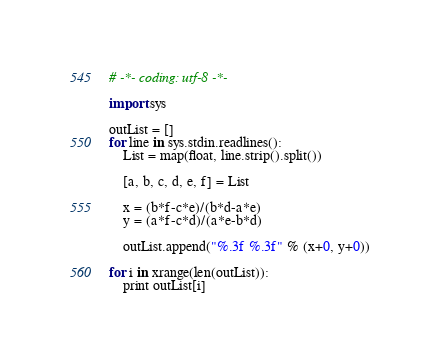Convert code to text. <code><loc_0><loc_0><loc_500><loc_500><_Python_># -*- coding: utf-8 -*-

import sys

outList = []
for line in sys.stdin.readlines():
    List = map(float, line.strip().split())

    [a, b, c, d, e, f] = List

    x = (b*f-c*e)/(b*d-a*e)
    y = (a*f-c*d)/(a*e-b*d)

    outList.append("%.3f %.3f" % (x+0, y+0))

for i in xrange(len(outList)):
    print outList[i]</code> 